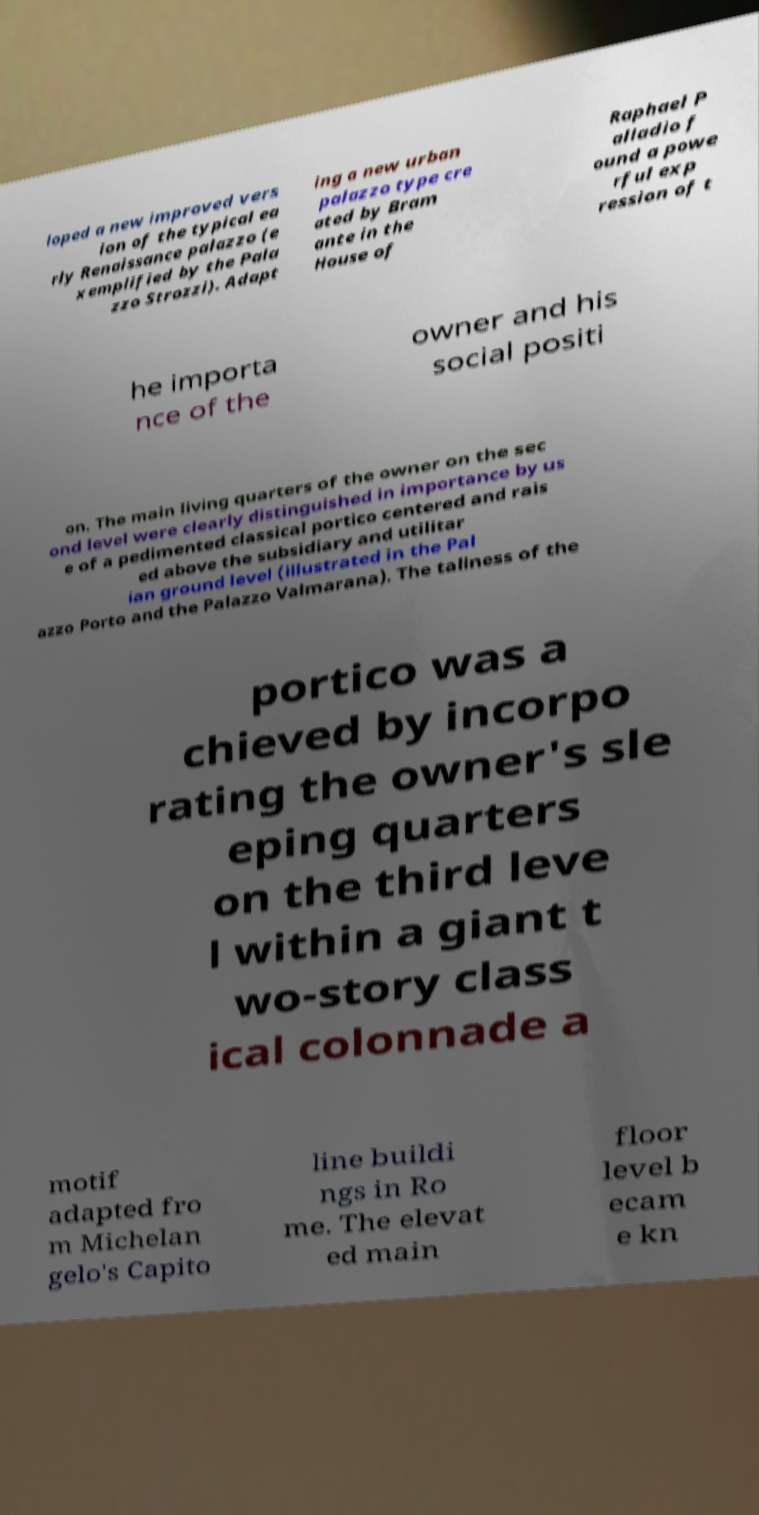Please read and relay the text visible in this image. What does it say? loped a new improved vers ion of the typical ea rly Renaissance palazzo (e xemplified by the Pala zzo Strozzi). Adapt ing a new urban palazzo type cre ated by Bram ante in the House of Raphael P alladio f ound a powe rful exp ression of t he importa nce of the owner and his social positi on. The main living quarters of the owner on the sec ond level were clearly distinguished in importance by us e of a pedimented classical portico centered and rais ed above the subsidiary and utilitar ian ground level (illustrated in the Pal azzo Porto and the Palazzo Valmarana). The tallness of the portico was a chieved by incorpo rating the owner's sle eping quarters on the third leve l within a giant t wo-story class ical colonnade a motif adapted fro m Michelan gelo's Capito line buildi ngs in Ro me. The elevat ed main floor level b ecam e kn 